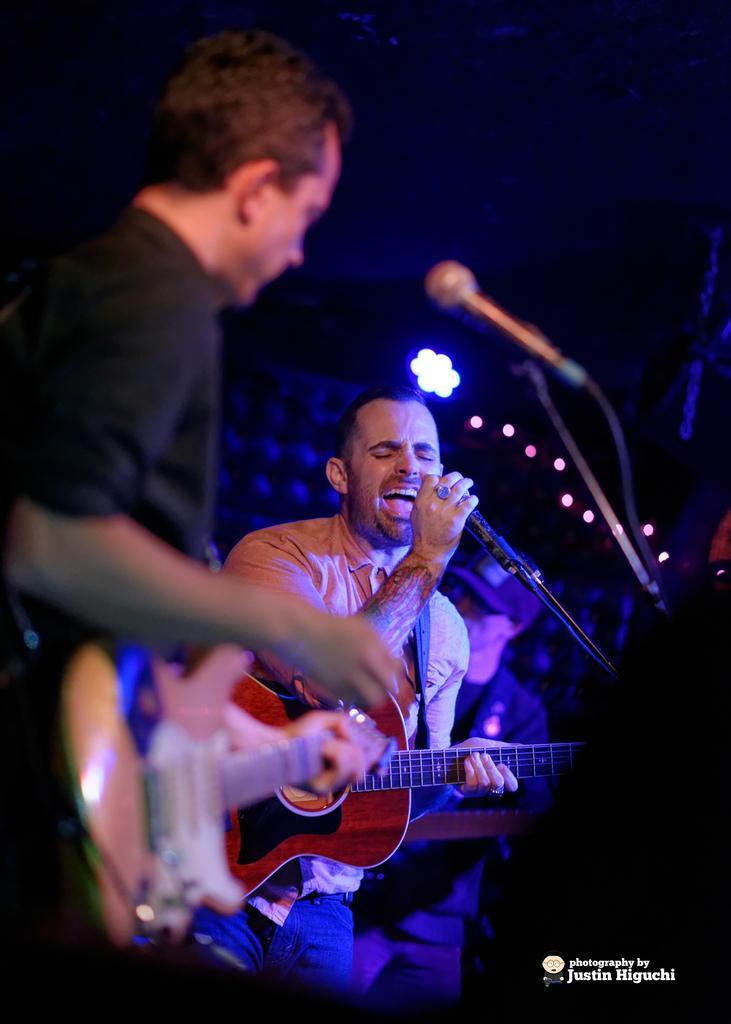Please provide a concise description of this image. This is a picture taken in the dark, there are two people performing the music. The man in black shirt holding a guitar and the other man is also holding a guitar and singing a song. Background of this people is a light. 